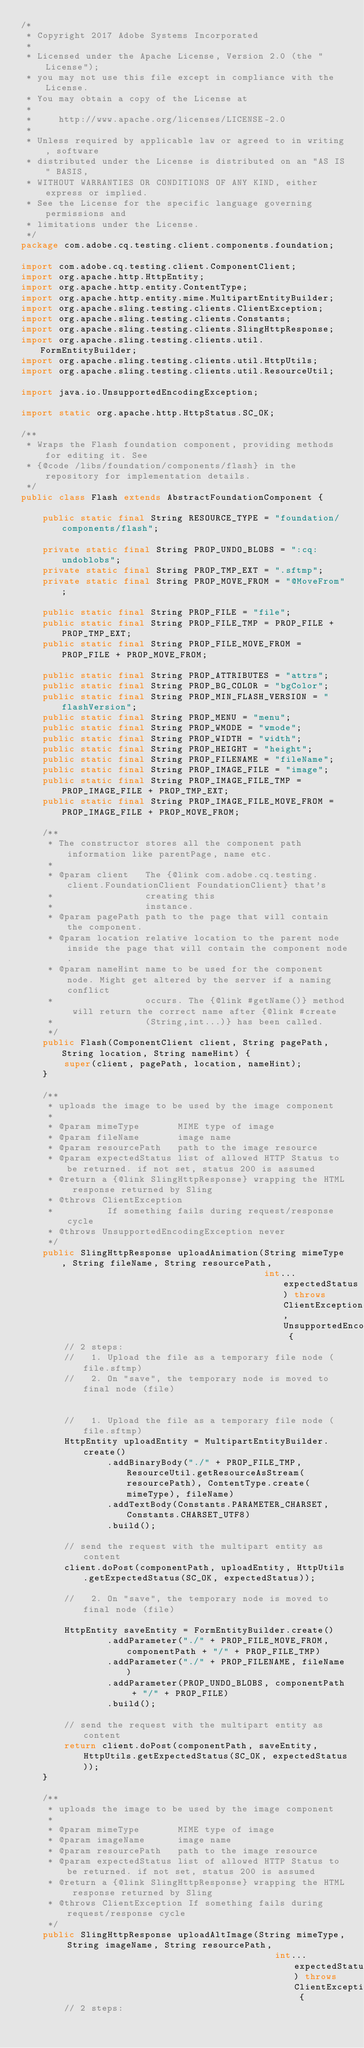<code> <loc_0><loc_0><loc_500><loc_500><_Java_>/*
 * Copyright 2017 Adobe Systems Incorporated
 *
 * Licensed under the Apache License, Version 2.0 (the "License");
 * you may not use this file except in compliance with the License.
 * You may obtain a copy of the License at
 *
 *     http://www.apache.org/licenses/LICENSE-2.0
 *
 * Unless required by applicable law or agreed to in writing, software
 * distributed under the License is distributed on an "AS IS" BASIS,
 * WITHOUT WARRANTIES OR CONDITIONS OF ANY KIND, either express or implied.
 * See the License for the specific language governing permissions and
 * limitations under the License.
 */
package com.adobe.cq.testing.client.components.foundation;

import com.adobe.cq.testing.client.ComponentClient;
import org.apache.http.HttpEntity;
import org.apache.http.entity.ContentType;
import org.apache.http.entity.mime.MultipartEntityBuilder;
import org.apache.sling.testing.clients.ClientException;
import org.apache.sling.testing.clients.Constants;
import org.apache.sling.testing.clients.SlingHttpResponse;
import org.apache.sling.testing.clients.util.FormEntityBuilder;
import org.apache.sling.testing.clients.util.HttpUtils;
import org.apache.sling.testing.clients.util.ResourceUtil;

import java.io.UnsupportedEncodingException;

import static org.apache.http.HttpStatus.SC_OK;

/**
 * Wraps the Flash foundation component, providing methods for editing it. See
 * {@code /libs/foundation/components/flash} in the repository for implementation details.
 */
public class Flash extends AbstractFoundationComponent {

    public static final String RESOURCE_TYPE = "foundation/components/flash";

    private static final String PROP_UNDO_BLOBS = ":cq:undoblobs";
    private static final String PROP_TMP_EXT = ".sftmp";
    private static final String PROP_MOVE_FROM = "@MoveFrom";

    public static final String PROP_FILE = "file";
    public static final String PROP_FILE_TMP = PROP_FILE + PROP_TMP_EXT;
    public static final String PROP_FILE_MOVE_FROM = PROP_FILE + PROP_MOVE_FROM;

    public static final String PROP_ATTRIBUTES = "attrs";
    public static final String PROP_BG_COLOR = "bgColor";
    public static final String PROP_MIN_FLASH_VERSION = "flashVersion";
    public static final String PROP_MENU = "menu";
    public static final String PROP_WMODE = "wmode";
    public static final String PROP_WIDTH = "width";
    public static final String PROP_HEIGHT = "height";
    public static final String PROP_FILENAME = "fileName";
    public static final String PROP_IMAGE_FILE = "image";
    public static final String PROP_IMAGE_FILE_TMP = PROP_IMAGE_FILE + PROP_TMP_EXT;
    public static final String PROP_IMAGE_FILE_MOVE_FROM = PROP_IMAGE_FILE + PROP_MOVE_FROM;

    /**
     * The constructor stores all the component path information like parentPage, name etc.
     *
     * @param client   The {@link com.adobe.cq.testing.client.FoundationClient FoundationClient} that's
     *                 creating this
     *                 instance.
     * @param pagePath path to the page that will contain the component.
     * @param location relative location to the parent node inside the page that will contain the component node.
     * @param nameHint name to be used for the component node. Might get altered by the server if a naming conflict
     *                 occurs. The {@link #getName()} method will return the correct name after {@link #create
     *                 (String,int...)} has been called.
     */
    public Flash(ComponentClient client, String pagePath, String location, String nameHint) {
        super(client, pagePath, location, nameHint);
    }

    /**
     * uploads the image to be used by the image component
     *
     * @param mimeType       MIME type of image
     * @param fileName       image name
     * @param resourcePath   path to the image resource
     * @param expectedStatus list of allowed HTTP Status to be returned. if not set, status 200 is assumed
     * @return a {@link SlingHttpResponse} wrapping the HTML response returned by Sling
     * @throws ClientException
     *          If something fails during request/response cycle
     * @throws UnsupportedEncodingException never
     */
    public SlingHttpResponse uploadAnimation(String mimeType, String fileName, String resourcePath,
                                             int... expectedStatus) throws ClientException, UnsupportedEncodingException {
        // 2 steps:
        //   1. Upload the file as a temporary file node (file.sftmp)
        //   2. On "save", the temporary node is moved to final node (file)


        //   1. Upload the file as a temporary file node (file.sftmp)
        HttpEntity uploadEntity = MultipartEntityBuilder.create()
                .addBinaryBody("./" + PROP_FILE_TMP, ResourceUtil.getResourceAsStream(resourcePath), ContentType.create(mimeType), fileName)
                .addTextBody(Constants.PARAMETER_CHARSET, Constants.CHARSET_UTF8)
                .build();

        // send the request with the multipart entity as content
        client.doPost(componentPath, uploadEntity, HttpUtils.getExpectedStatus(SC_OK, expectedStatus));

        //   2. On "save", the temporary node is moved to final node (file)

        HttpEntity saveEntity = FormEntityBuilder.create()
                .addParameter("./" + PROP_FILE_MOVE_FROM, componentPath + "/" + PROP_FILE_TMP)
                .addParameter("./" + PROP_FILENAME, fileName)
                .addParameter(PROP_UNDO_BLOBS, componentPath + "/" + PROP_FILE)
                .build();

        // send the request with the multipart entity as content
        return client.doPost(componentPath, saveEntity, HttpUtils.getExpectedStatus(SC_OK, expectedStatus));
    }

    /**
     * uploads the image to be used by the image component
     *
     * @param mimeType       MIME type of image
     * @param imageName      image name
     * @param resourcePath   path to the image resource
     * @param expectedStatus list of allowed HTTP Status to be returned. if not set, status 200 is assumed
     * @return a {@link SlingHttpResponse} wrapping the HTML response returned by Sling
     * @throws ClientException If something fails during request/response cycle
     */
    public SlingHttpResponse uploadAltImage(String mimeType, String imageName, String resourcePath,
                                               int... expectedStatus) throws ClientException {
        // 2 steps:</code> 